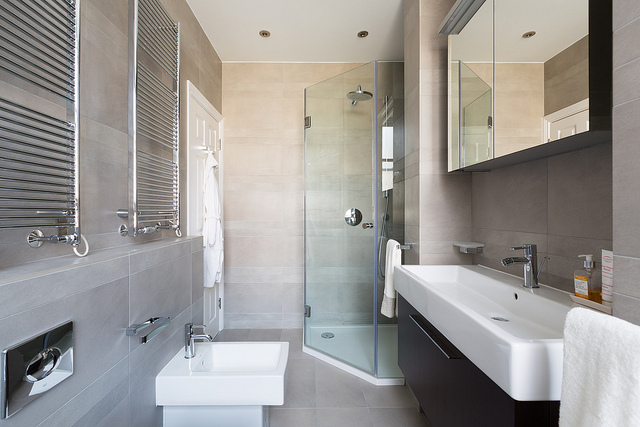Does this bathroom seem accessible for people with disabilities? From the visible layout, the bathroom does not appear to be specifically designed for accessibility. Standard accessibility features, such as grab bars next to the toilet or in the shower and ample space for wheelchair maneuverability, are not evident in this image. However, the walk-in shower may offer some level of accessibility, but without additional adaptations, it cannot be considered fully accessible.  What kind of lighting solutions are present in this bathroom? The image shows a bright and naturally lit bathroom, courtesy of the light coming through the windows with adjustable blinds. There also appears to be ceiling recessed lights that would provide ample artificial lighting. The mirror could potentially have an integrated light to illuminate the face evenly, which is common in modern bathroom designs. 